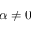Convert formula to latex. <formula><loc_0><loc_0><loc_500><loc_500>\alpha \neq 0</formula> 